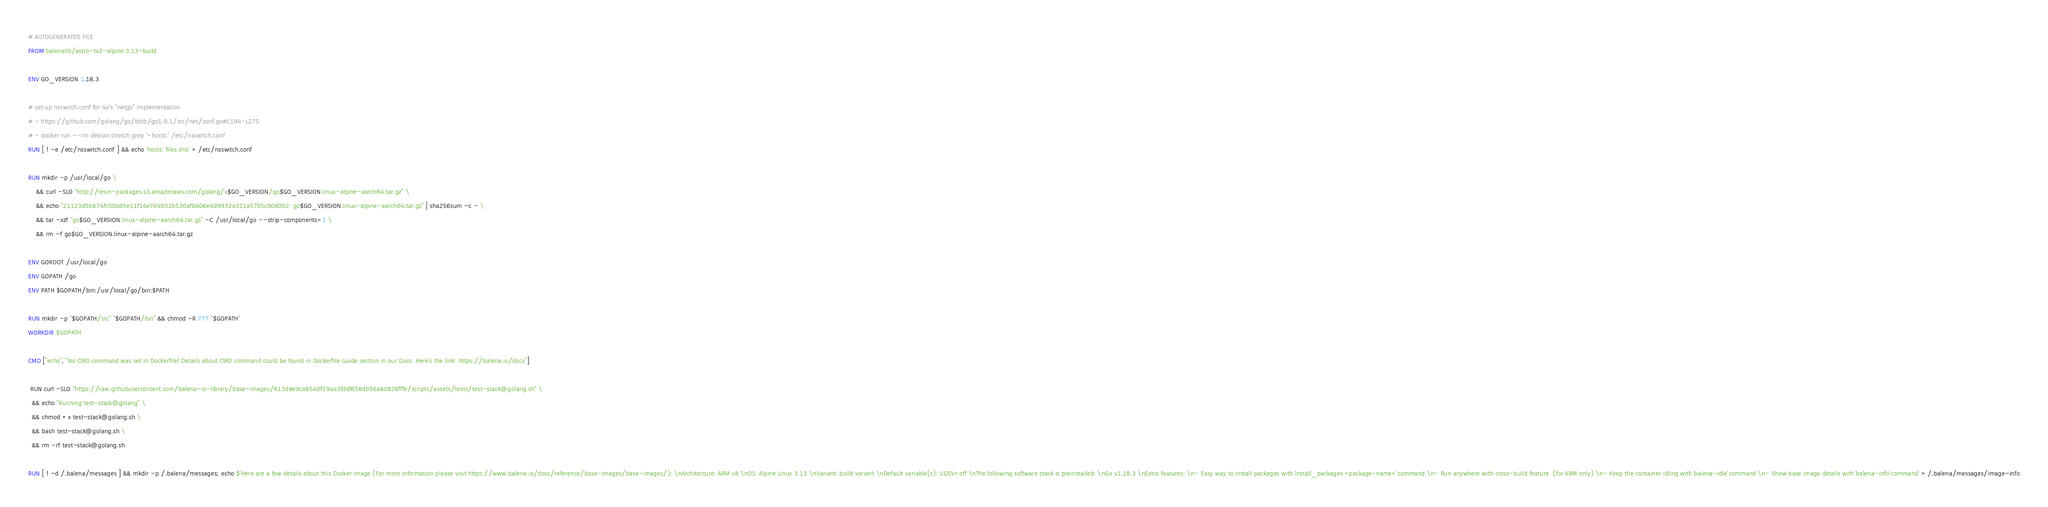Convert code to text. <code><loc_0><loc_0><loc_500><loc_500><_Dockerfile_># AUTOGENERATED FILE
FROM balenalib/astro-tx2-alpine:3.13-build

ENV GO_VERSION 1.18.3

# set up nsswitch.conf for Go's "netgo" implementation
# - https://github.com/golang/go/blob/go1.9.1/src/net/conf.go#L194-L275
# - docker run --rm debian:stretch grep '^hosts:' /etc/nsswitch.conf
RUN [ ! -e /etc/nsswitch.conf ] && echo 'hosts: files dns' > /etc/nsswitch.conf

RUN mkdir -p /usr/local/go \
	&& curl -SLO "http://resin-packages.s3.amazonaws.com/golang/v$GO_VERSION/go$GO_VERSION.linux-alpine-aarch64.tar.gz" \
	&& echo "21123d5b674fc00b85e11f14e7d4032b530afb406e499932a311a57b5c90d002  go$GO_VERSION.linux-alpine-aarch64.tar.gz" | sha256sum -c - \
	&& tar -xzf "go$GO_VERSION.linux-alpine-aarch64.tar.gz" -C /usr/local/go --strip-components=1 \
	&& rm -f go$GO_VERSION.linux-alpine-aarch64.tar.gz

ENV GOROOT /usr/local/go
ENV GOPATH /go
ENV PATH $GOPATH/bin:/usr/local/go/bin:$PATH

RUN mkdir -p "$GOPATH/src" "$GOPATH/bin" && chmod -R 777 "$GOPATH"
WORKDIR $GOPATH

CMD ["echo","'No CMD command was set in Dockerfile! Details about CMD command could be found in Dockerfile Guide section in our Docs. Here's the link: https://balena.io/docs"]

 RUN curl -SLO "https://raw.githubusercontent.com/balena-io-library/base-images/613d8e9ca8540f29a43fddf658db56a8d826fffe/scripts/assets/tests/test-stack@golang.sh" \
  && echo "Running test-stack@golang" \
  && chmod +x test-stack@golang.sh \
  && bash test-stack@golang.sh \
  && rm -rf test-stack@golang.sh 

RUN [ ! -d /.balena/messages ] && mkdir -p /.balena/messages; echo $'Here are a few details about this Docker image (For more information please visit https://www.balena.io/docs/reference/base-images/base-images/): \nArchitecture: ARM v8 \nOS: Alpine Linux 3.13 \nVariant: build variant \nDefault variable(s): UDEV=off \nThe following software stack is preinstalled: \nGo v1.18.3 \nExtra features: \n- Easy way to install packages with `install_packages <package-name>` command \n- Run anywhere with cross-build feature  (for ARM only) \n- Keep the container idling with `balena-idle` command \n- Show base image details with `balena-info` command' > /.balena/messages/image-info</code> 